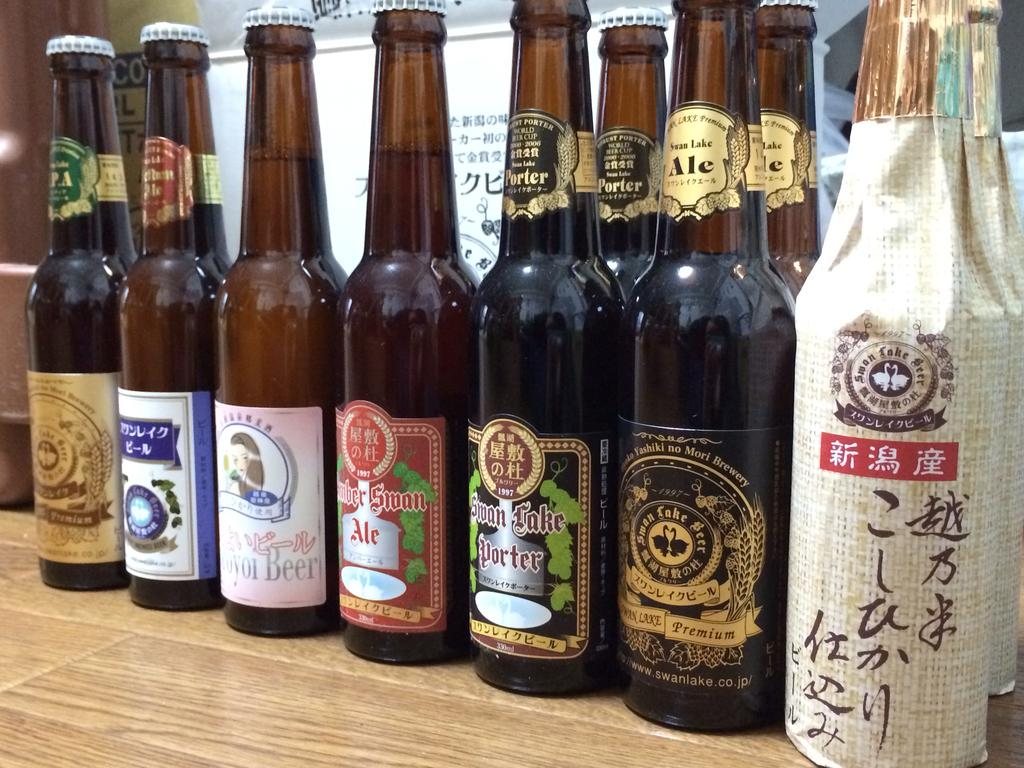<image>
Create a compact narrative representing the image presented. Several bottles of alcohol including swan lake ale. 